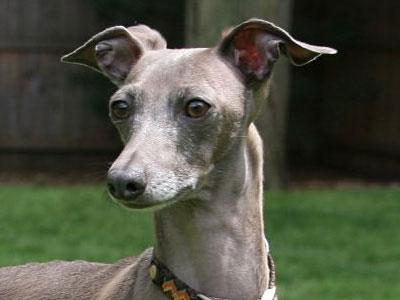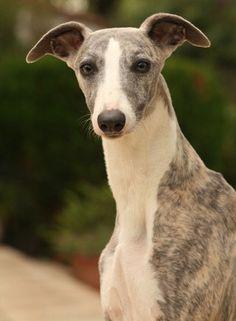The first image is the image on the left, the second image is the image on the right. Considering the images on both sides, is "One dog has a collar on." valid? Answer yes or no. Yes. 